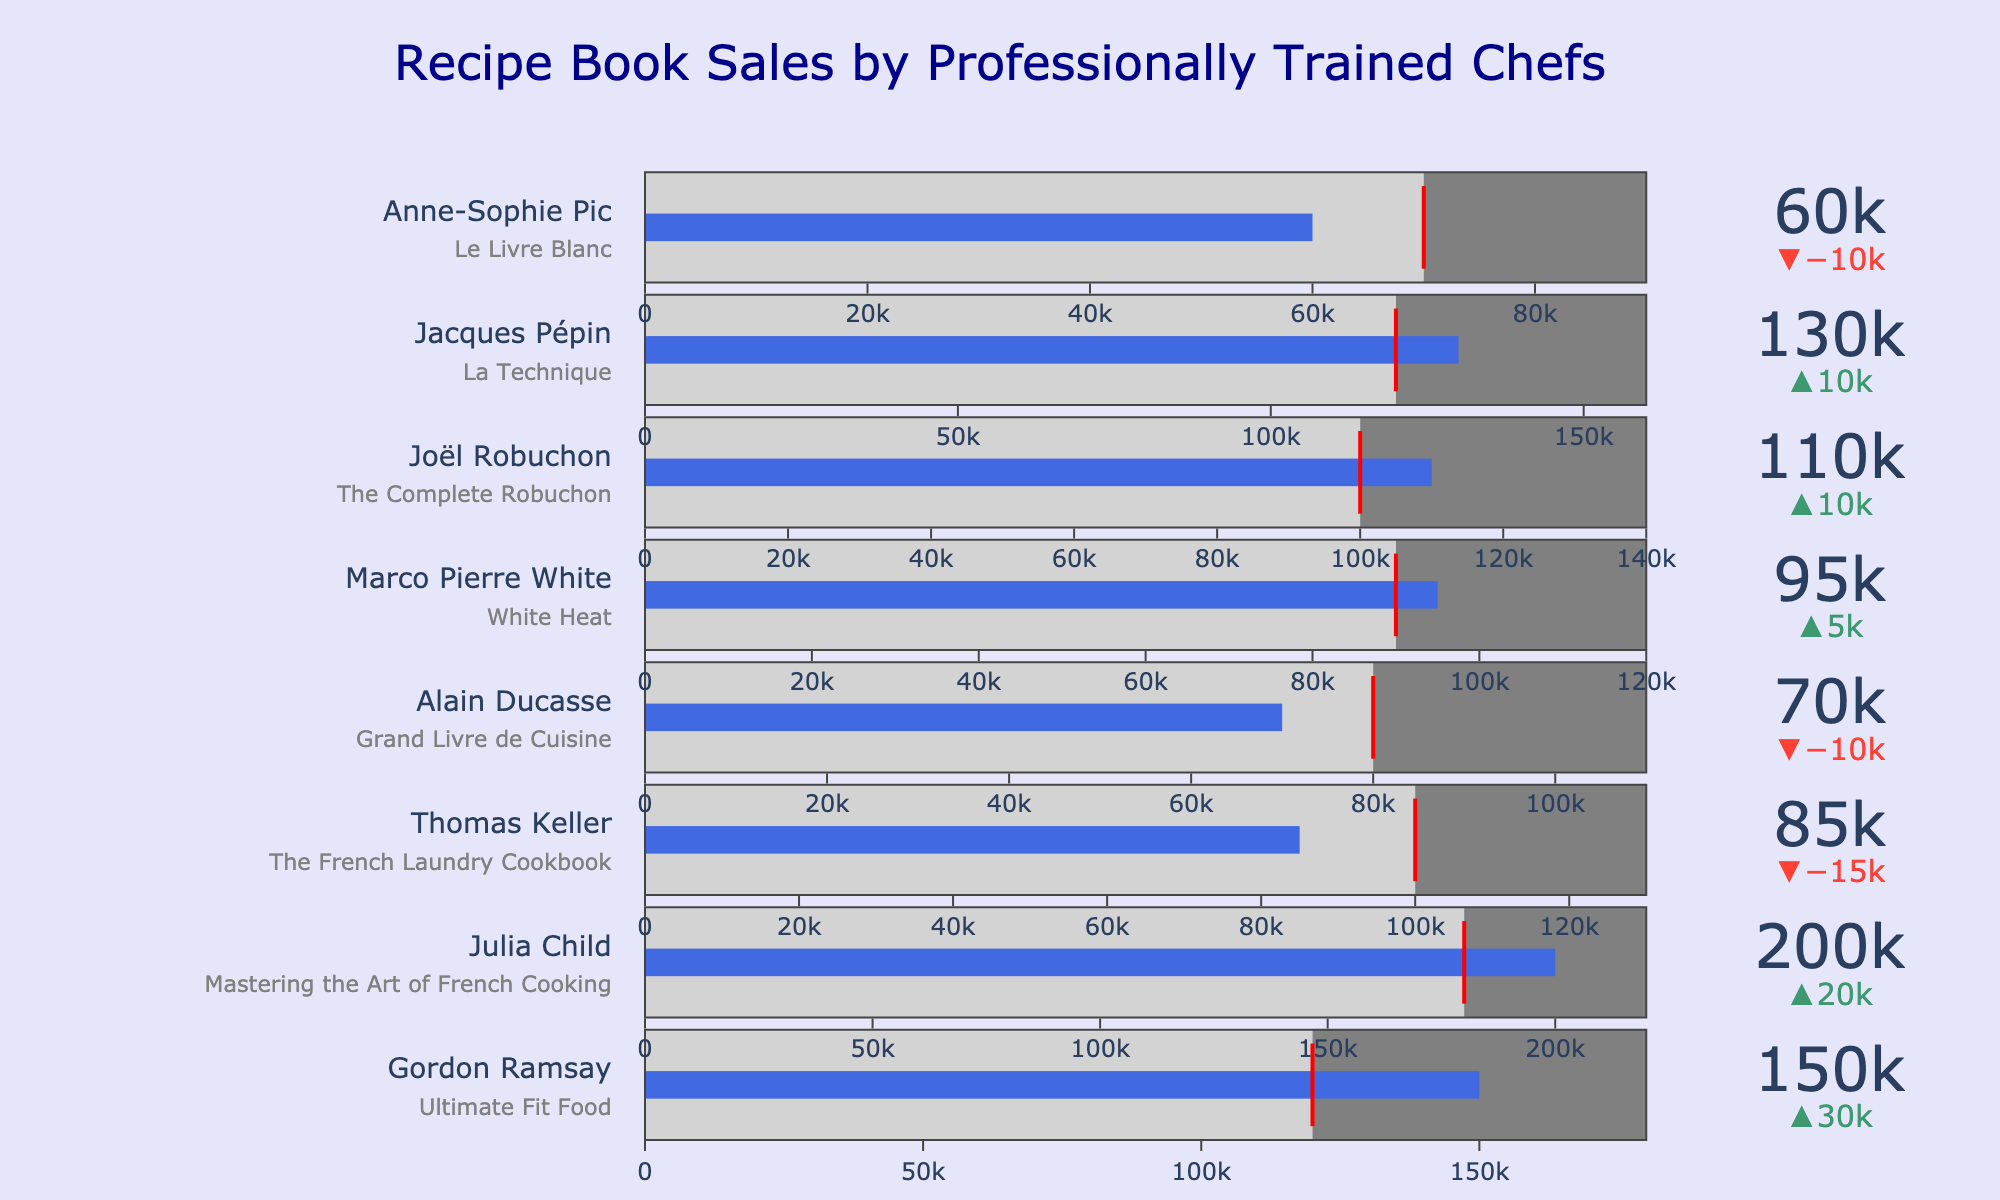What's the title of the chart? The title of any chart is typically provided at the top. In this chart, the title is clearly written at the top center of the figure in a larger font size for emphasis.
Answer: Recipe Book Sales by Professionally Trained Chefs Who has the highest actual sales? By visually inspecting the lengths of the bars, we can see that Julia Child has the longest bar, indicating the highest actual sales.
Answer: Julia Child Which chef's actual sales exceeded their target by the largest amount? To find this information, look at the delta (difference) between actual sales and target sales for each chef. Comparing all deltas, Julia Child has the largest positive difference.
Answer: Julia Child How many chefs had actual sales below their target? By examining the placement of the blue bars in relation to the red threshold lines, Thomas Keller, Alain Ducasse, and Anne-Sophie Pic have their actual sales bars (blue) below the target (red line).
Answer: 3 What is the combined total of actual sales for chefs who met or exceeded their targets? Gordon Ramsay, Julia Child, Marco Pierre White, Joël Robuchon, and Jacques Pépin met or exceeded their targets. Sum their sales: 150,000 + 200,000 + 95,000 + 110,000 + 130,000 = 685,000
Answer: 685,000 Which chef had the closest actual sales to their target without exceeding it? By comparing the differences between actual sales and targets among those who did not exceed their targets, Thomas Keller has the smallest difference (85,000 - 100,000 = -15,000).
Answer: Thomas Keller Are there any chefs whose actual sales range lies entirely within the light gray area? The light gray area represents sales below the target. Chefs whose bars are fully contained within this area have actual sales below their target. Anne-Sophie Pic is an example.
Answer: Anne-Sophie Pic Which chef's sales bar is the shortest but still exceeds their target? By looking at the shortest blue bar that crosses the red threshold, Marco Pierre White has the shortest but exceeds the target.
Answer: Marco Pierre White 